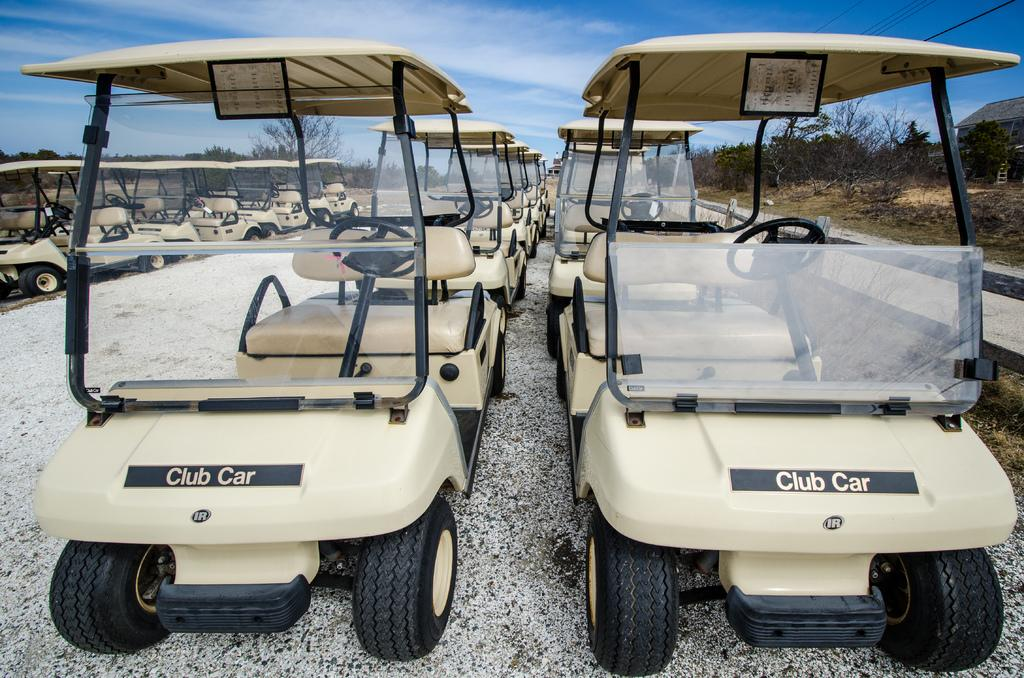What types of objects are present in the image? There are vehicles in the image. What colors are the vehicles? The vehicles are in black and brown colors. What can be seen in the background of the image? There are trees and the sky visible in the background of the image. What color are the trees? The trees are in green color. What colors are visible in the sky? The sky is in blue and white colors. Can you see the cat's arm in the image? There is no cat or arm present in the image. 